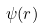<formula> <loc_0><loc_0><loc_500><loc_500>\psi ( r )</formula> 